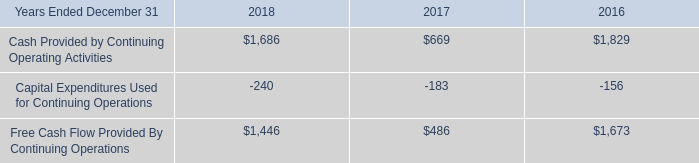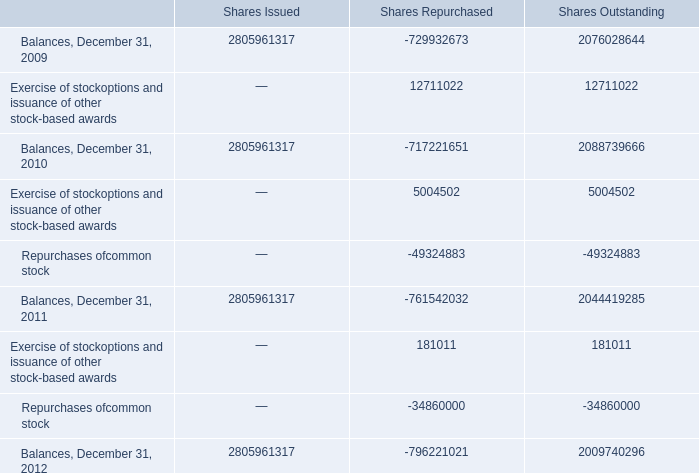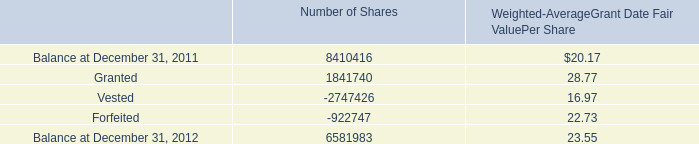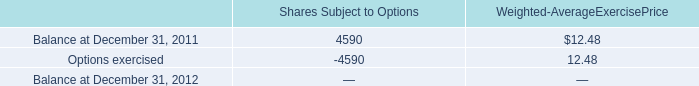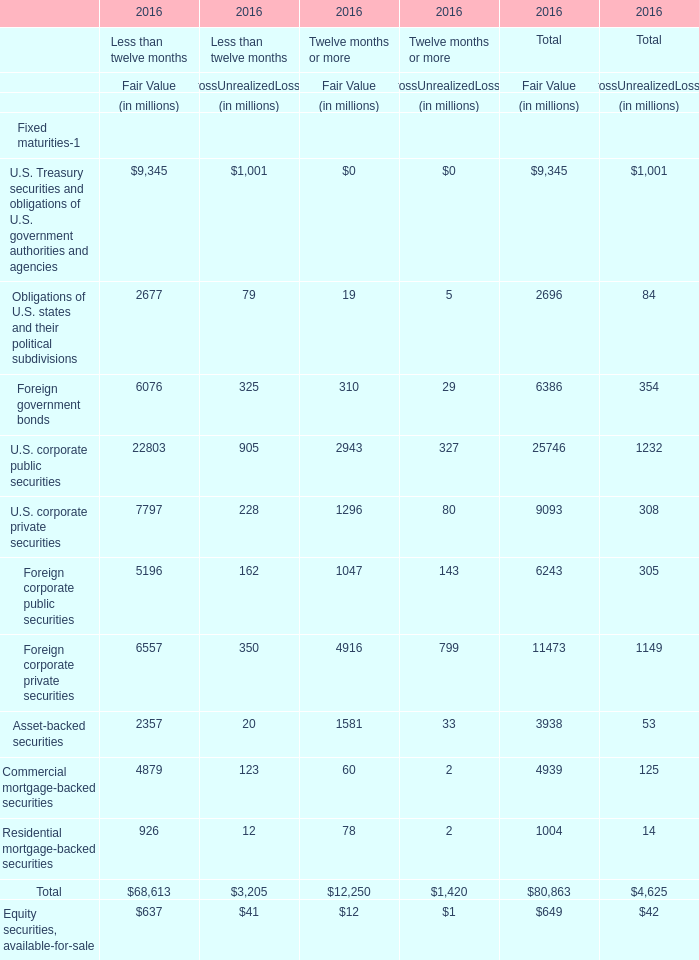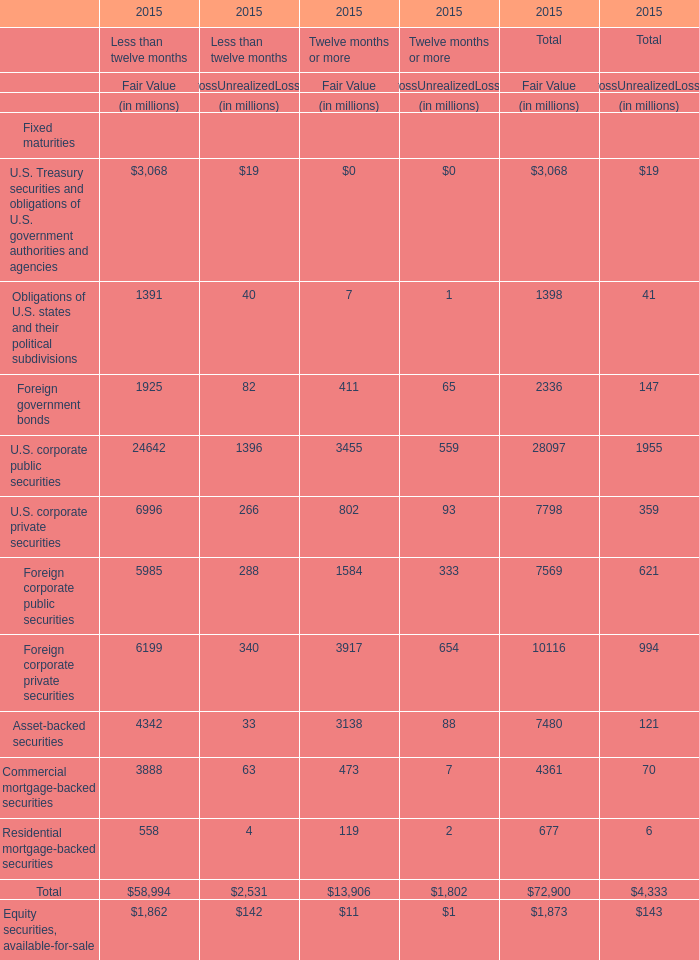In which section the sum of Foreign corporate private securities for GrossUnrealizedLosses has the highest value? 
Answer: Twelve months or more for GrossUnrealizedLosses. 